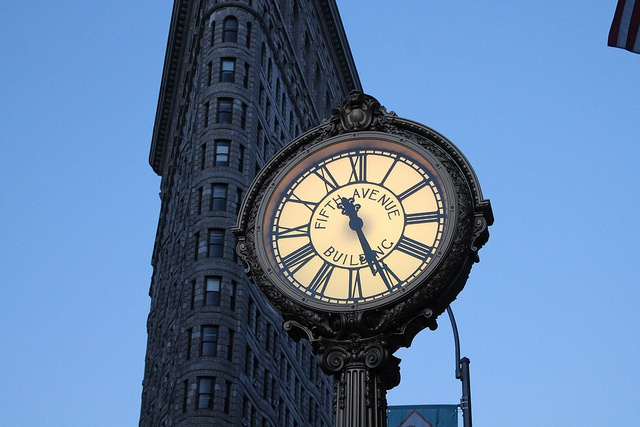Describe the objects in this image and their specific colors. I can see a clock in gray, khaki, navy, and darkblue tones in this image. 